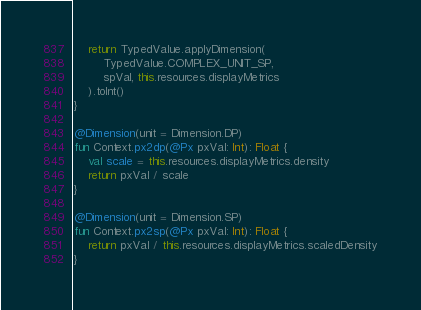<code> <loc_0><loc_0><loc_500><loc_500><_Kotlin_>    return TypedValue.applyDimension(
        TypedValue.COMPLEX_UNIT_SP,
        spVal, this.resources.displayMetrics
    ).toInt()
}

@Dimension(unit = Dimension.DP)
fun Context.px2dp(@Px pxVal: Int): Float {
    val scale = this.resources.displayMetrics.density
    return pxVal / scale
}

@Dimension(unit = Dimension.SP)
fun Context.px2sp(@Px pxVal: Int): Float {
    return pxVal / this.resources.displayMetrics.scaledDensity
}

</code> 